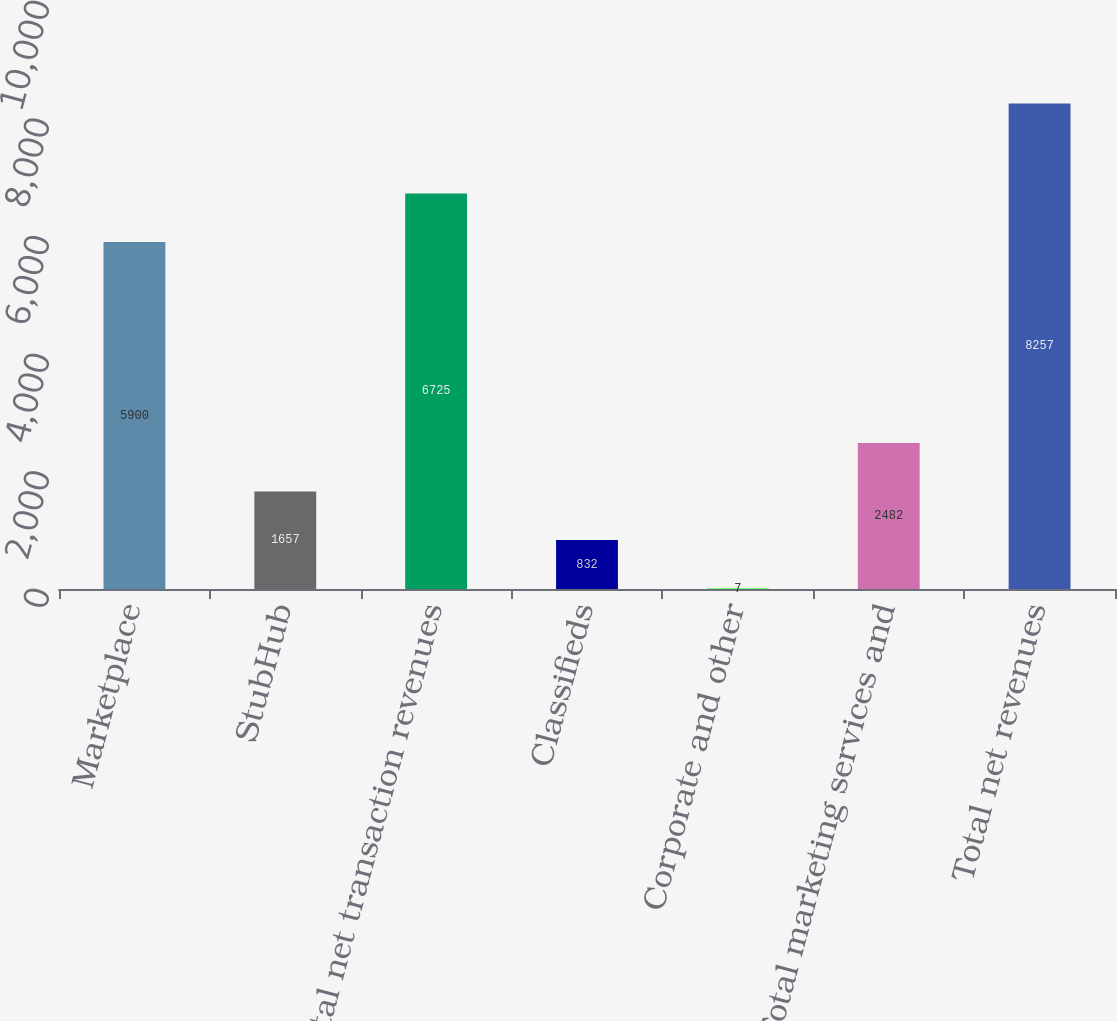Convert chart. <chart><loc_0><loc_0><loc_500><loc_500><bar_chart><fcel>Marketplace<fcel>StubHub<fcel>Total net transaction revenues<fcel>Classifieds<fcel>Corporate and other<fcel>Total marketing services and<fcel>Total net revenues<nl><fcel>5900<fcel>1657<fcel>6725<fcel>832<fcel>7<fcel>2482<fcel>8257<nl></chart> 